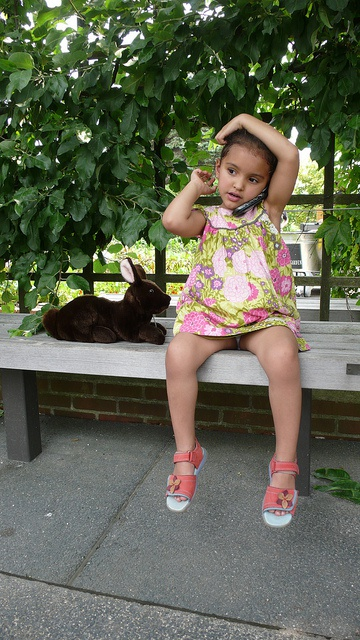Describe the objects in this image and their specific colors. I can see people in darkgreen, tan, brown, lightpink, and lavender tones, bench in darkgreen, darkgray, black, lightgray, and gray tones, dog in darkgreen, black, lightgray, maroon, and gray tones, and cell phone in darkgreen, black, gray, darkgray, and blue tones in this image. 